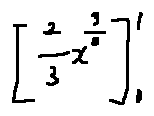Convert formula to latex. <formula><loc_0><loc_0><loc_500><loc_500>[ \frac { 2 } { 3 } x ^ { \frac { 3 } { 2 } } ] _ { 0 } ^ { 1 }</formula> 